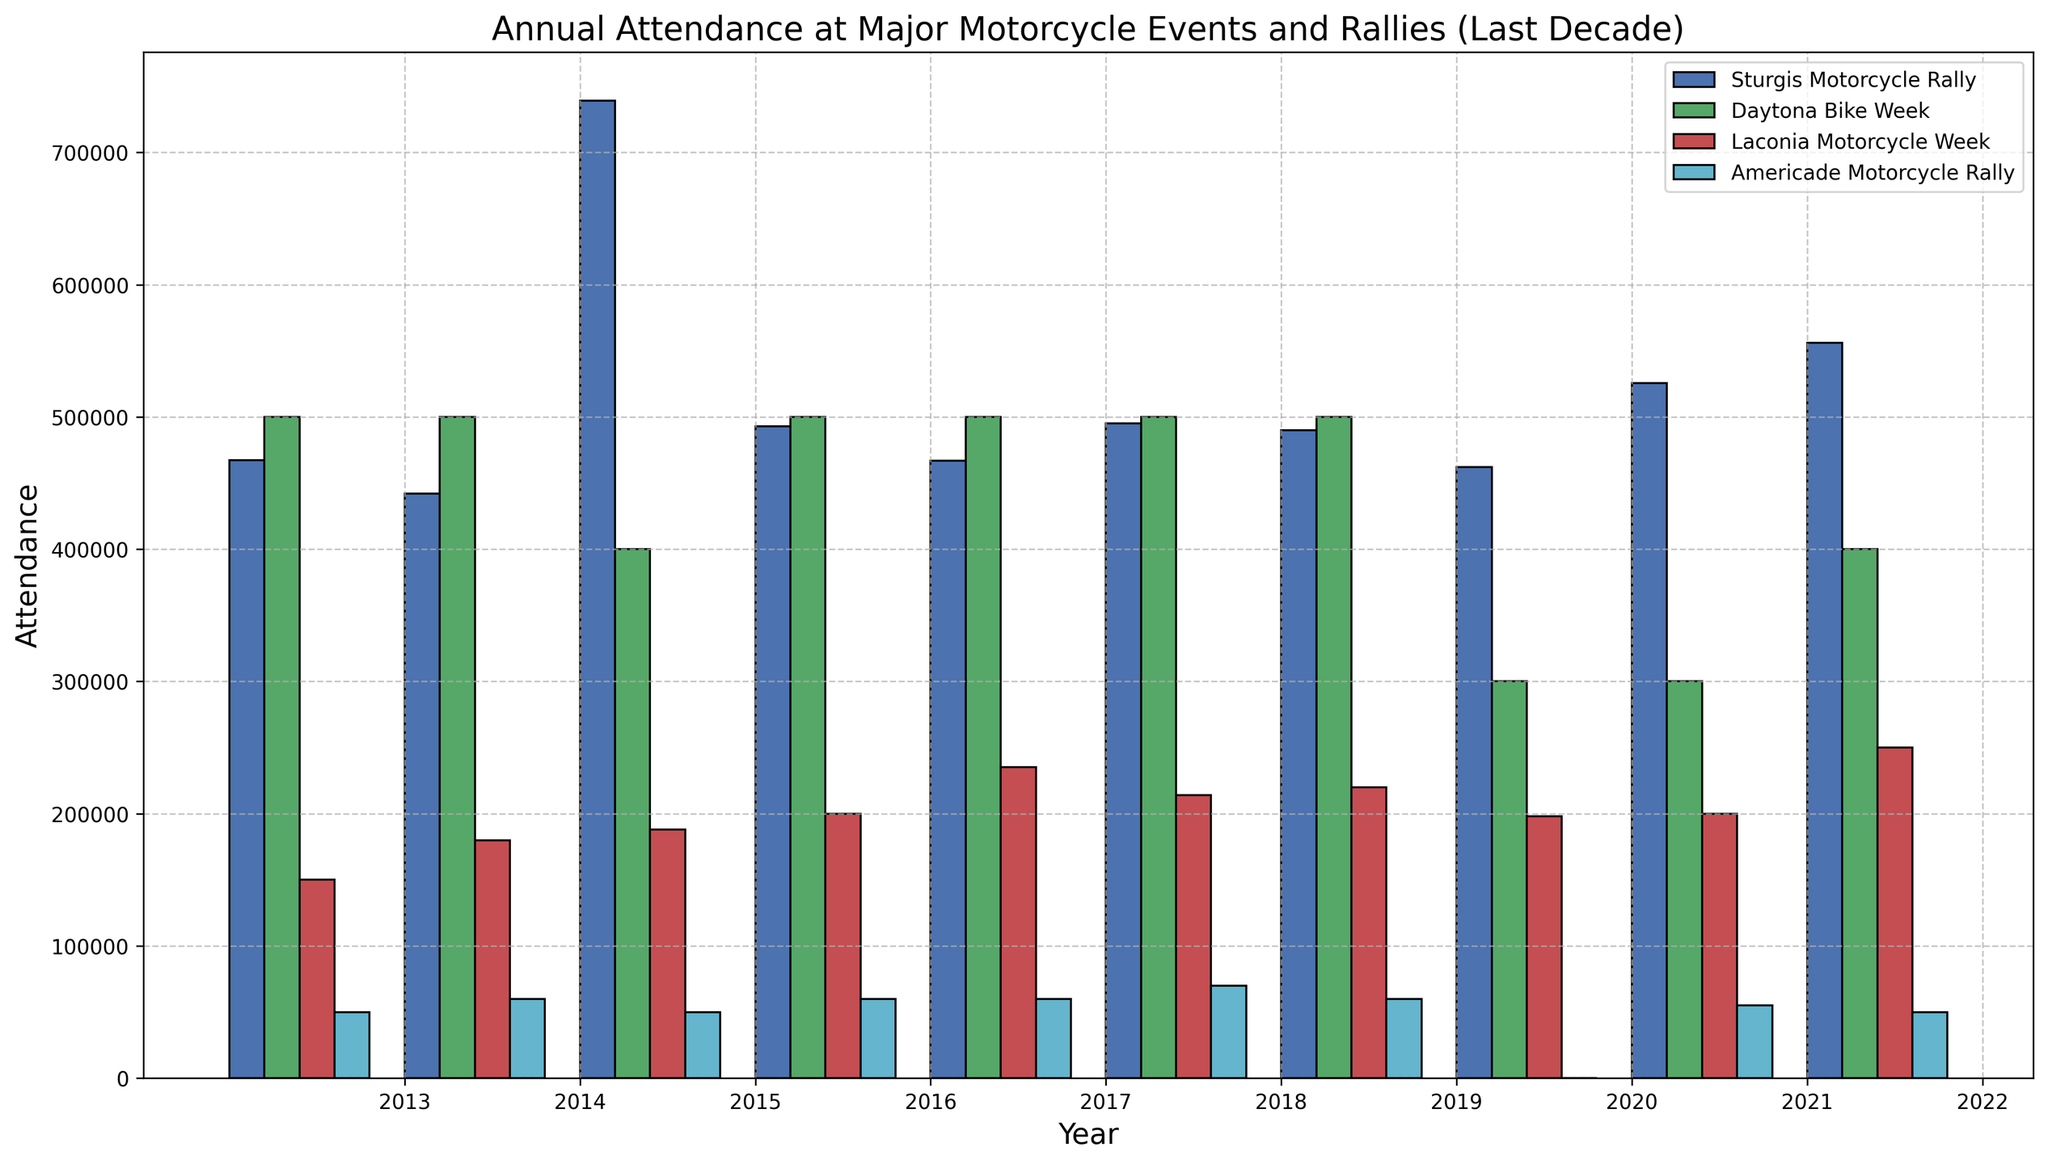What's the trend in attendance at the Sturgis Motorcycle Rally from 2013 to 2022? By looking at the heights of the bars for the Sturgis Motorcycle Rally from 2013 to 2022, we can observe the general pattern in the attendance figures over these years.
Answer: The attendance fluctuates with a significant peak in 2015 and a gradual increase from 2020 to 2022 Which motorcycle event had the lowest attendance in 2020? Comparing the heights of the bars for each event in 2020, we can identify which one has the shortest bar.
Answer: Americade Motorcycle Rally Which year did the Daytona Bike Week have the highest drop in attendance compared to the previous year? We find the largest difference between the heights of consecutive bars for Daytona Bike Week. The biggest drop is between the bars for 2019 and 2020.
Answer: 2020 How does the attendance in 2022 for Laconia Motorcycle Week compare to its attendance in 2013? By comparing the heights of the bars for Laconia Motorcycle Week in 2022 and 2013, we can see the difference. The attendance in 2022 is higher than in 2013.
Answer: The attendance in 2022 is higher Calculate the average attendance of Americade Motorcycle Rally from 2018 to 2022, excluding 2020. We sum up the attendance figures for Americade Motorcycle Rally from 2018, 2019, 2021, and 2022 and then divide by the number of years (4). The calculation is (70000 + 60000 + 55000 + 50000) / 4.
Answer: 58750 Which event had the highest attendance in any given year, and what was the year and attendance figure? By identifying the tallest bar in the entire plot and noting its corresponding event, year, and attendance figure. The highest bar represents the Sturgis Motorcycle Rally in 2015.
Answer: Sturgis Motorcycle Rally in 2015 with 739000 attendance In which year did the Laconia Motorcycle Week see its highest attendance from 2013 to 2022? By checking the heights of the bars for Laconia Motorcycle Week and identifying the tallest one within the specified years.
Answer: 2022 What is the overall trend in attendance for Daytona Bike Week between 2013 and 2022? Observing the height changes in the bars for Daytona Bike Week from 2013 to 2022 shows a consistent attendance until a drop in 2020, followed by partial recovery.
Answer: Mostly stable with a drop in 2020 and partial recovery afterward Compare the attendance growth rate of Sturgis Motorcycle Rally between 2021 and 2022 to the Americade Motorcycle Rally in the same years. Calculating the difference between the heights of bars for Sturgis Motorcycle Rally in 2021 and 2022 and comparing it with the difference in heights for Americade Motorcycle Rally for the same years. Sturgis increased by 30121, while Americade fell by 5000.
Answer: Sturgis increased more 